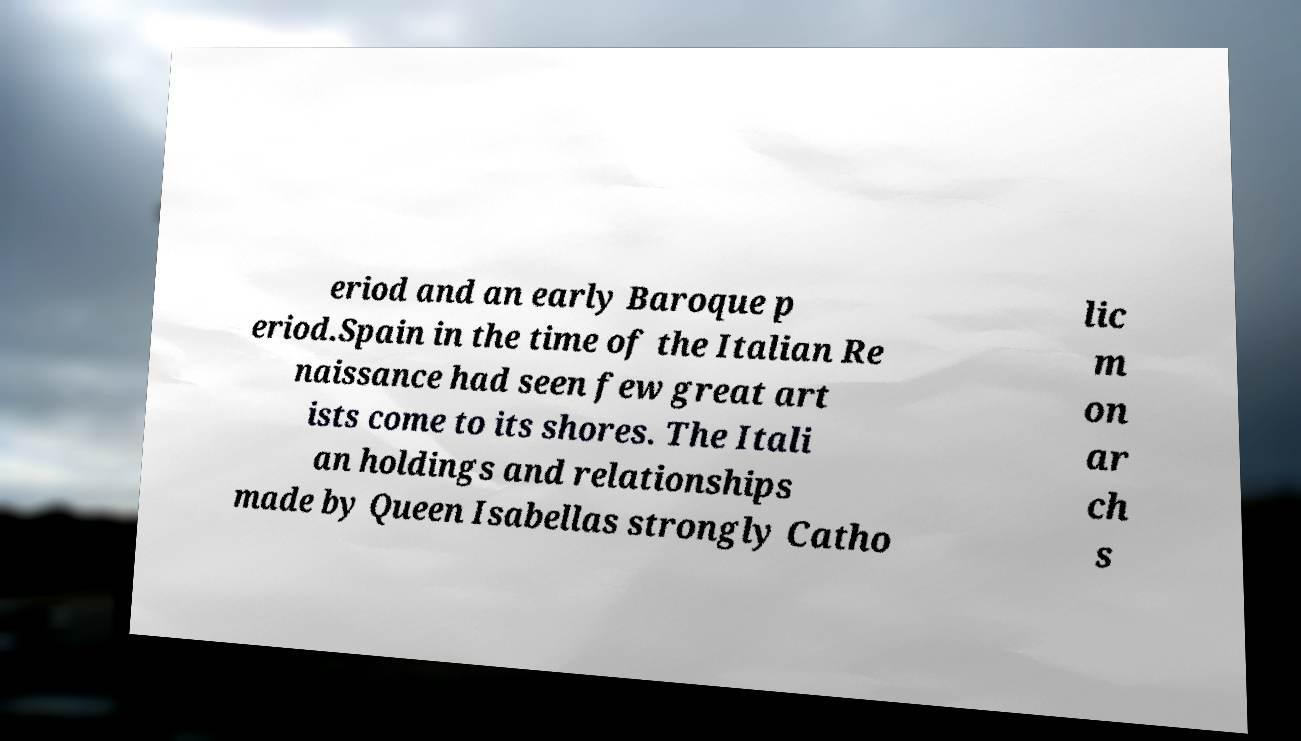Could you assist in decoding the text presented in this image and type it out clearly? eriod and an early Baroque p eriod.Spain in the time of the Italian Re naissance had seen few great art ists come to its shores. The Itali an holdings and relationships made by Queen Isabellas strongly Catho lic m on ar ch s 